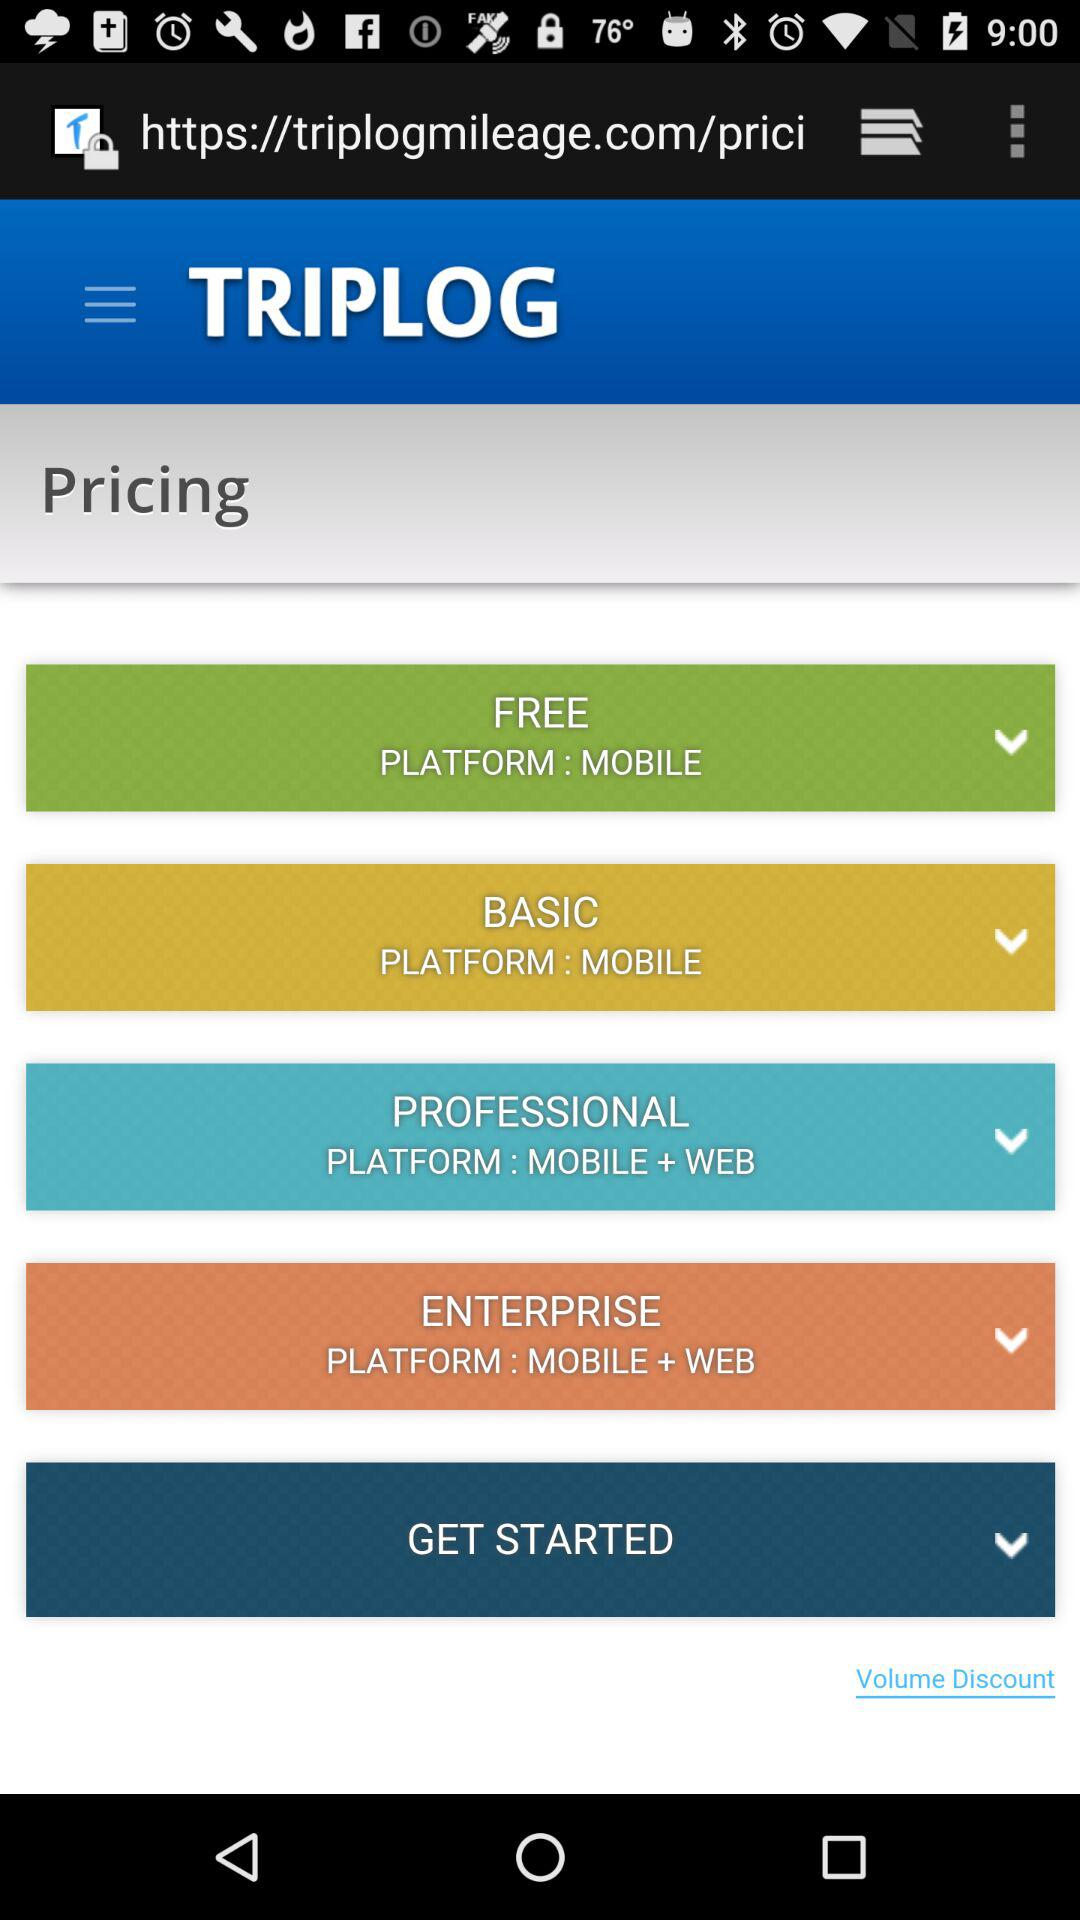Which plan is only accessible on the mobile platform? The plans "FREE" and "BASIC" are only accessible on the mobile platform. 